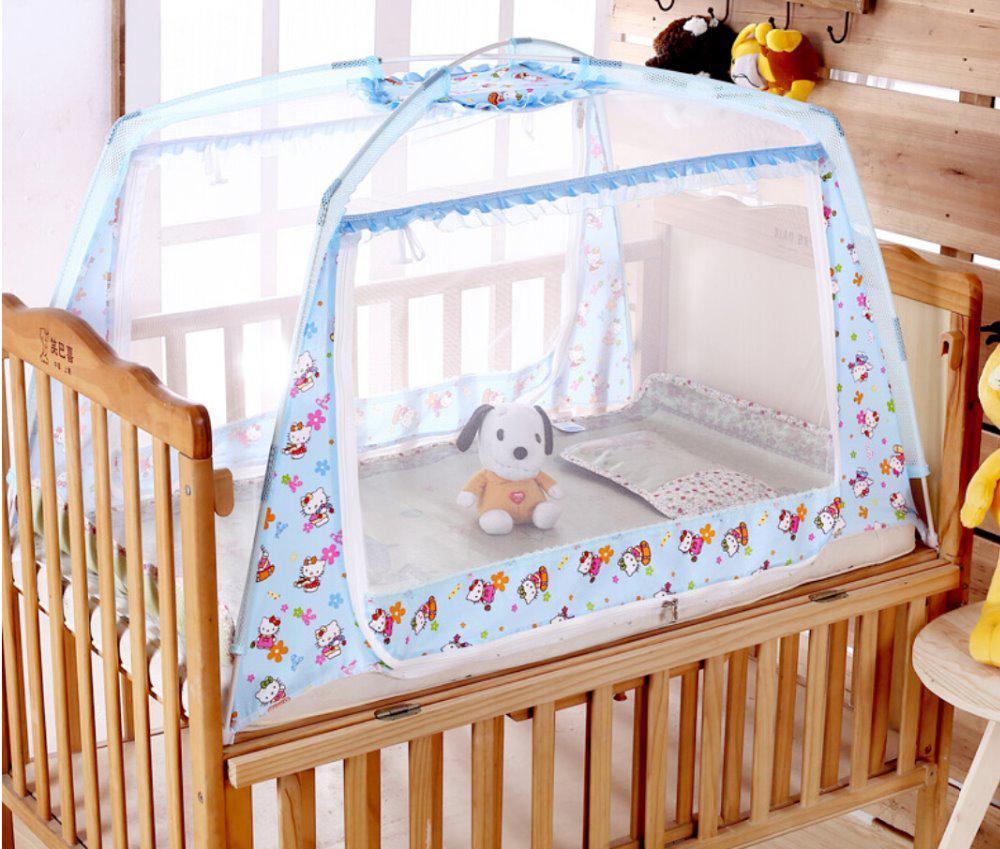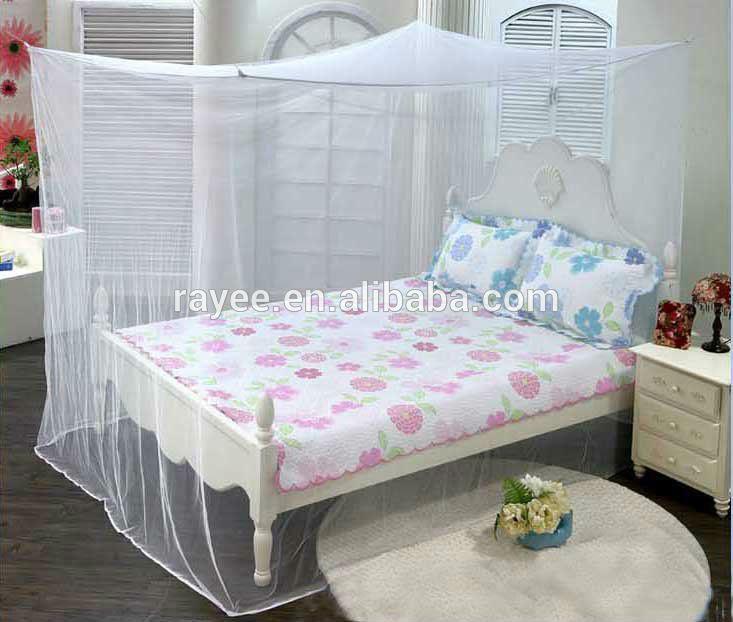The first image is the image on the left, the second image is the image on the right. Analyze the images presented: Is the assertion "There is a stuffed toy resting on one of the beds." valid? Answer yes or no. Yes. The first image is the image on the left, the second image is the image on the right. Assess this claim about the two images: "There is a stuffed animal on top of one of the beds.". Correct or not? Answer yes or no. Yes. 